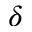<formula> <loc_0><loc_0><loc_500><loc_500>\delta</formula> 